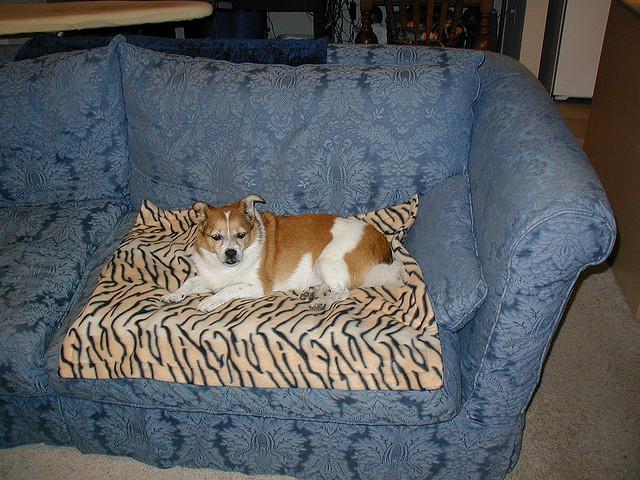What kind of design is the blanket that the dog is laying on?
Give a very brief answer. Tiger. What material is this chair made out of?
Concise answer only. Polyester. Which animal is this?
Keep it brief. Dog. Are there any pillows on the couch?
Answer briefly. Yes. Is the dog both brown and white?
Short answer required. Yes. 